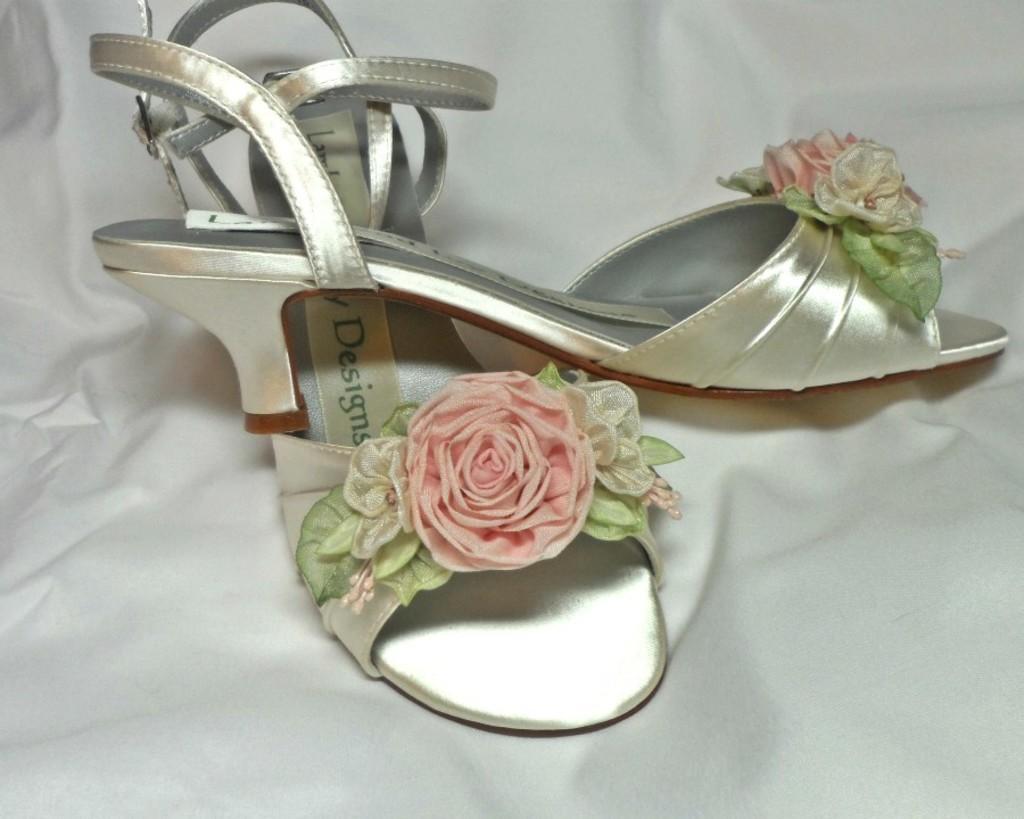How would you summarize this image in a sentence or two? In this picture I can see a pair of footwear on the cloth. 